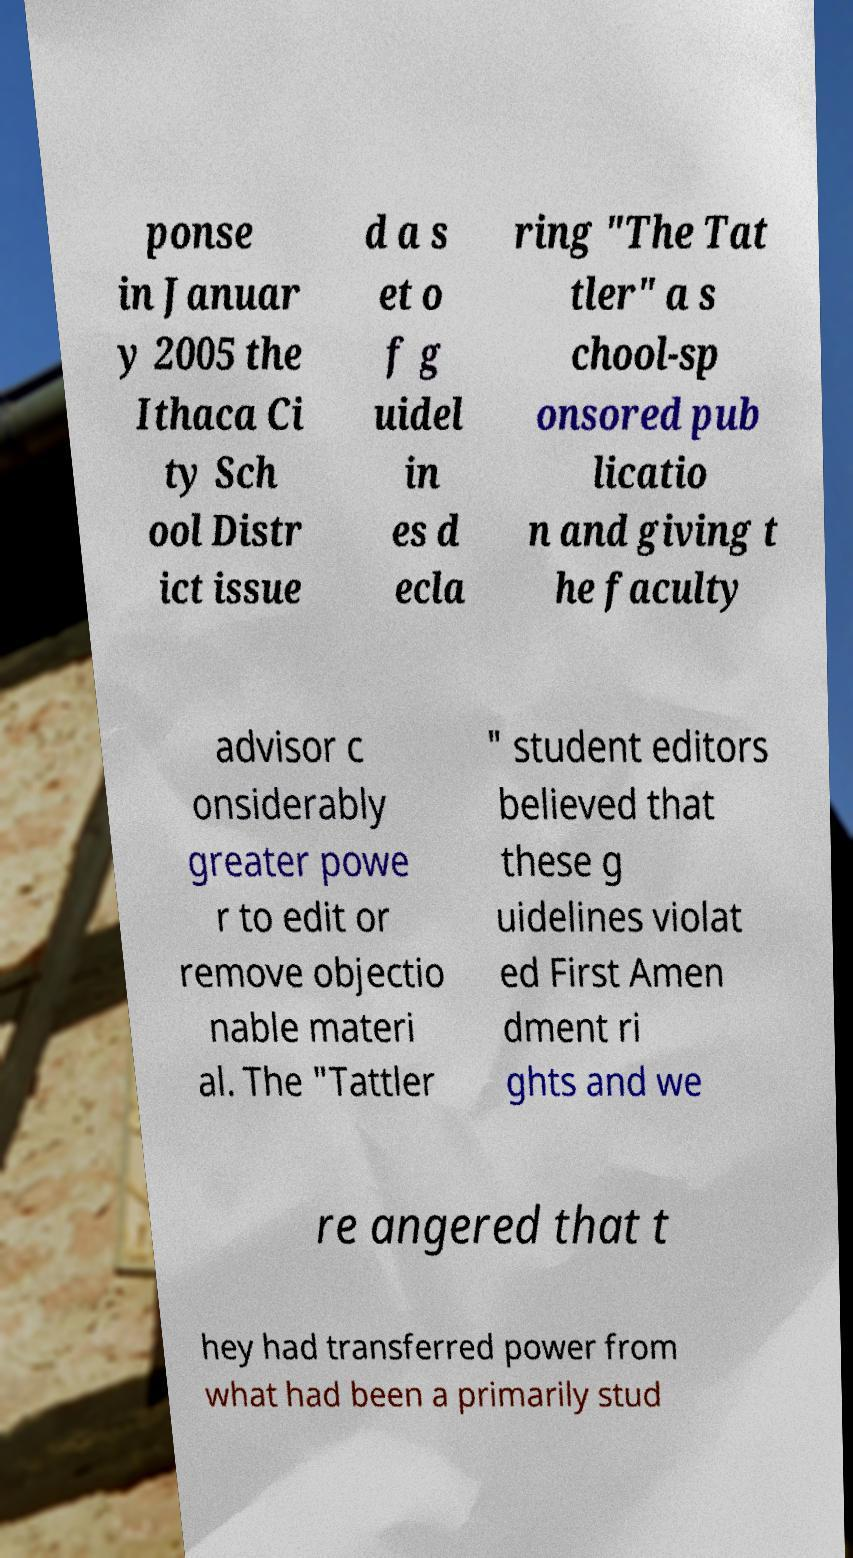Please identify and transcribe the text found in this image. ponse in Januar y 2005 the Ithaca Ci ty Sch ool Distr ict issue d a s et o f g uidel in es d ecla ring "The Tat tler" a s chool-sp onsored pub licatio n and giving t he faculty advisor c onsiderably greater powe r to edit or remove objectio nable materi al. The "Tattler " student editors believed that these g uidelines violat ed First Amen dment ri ghts and we re angered that t hey had transferred power from what had been a primarily stud 